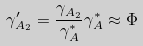Convert formula to latex. <formula><loc_0><loc_0><loc_500><loc_500>\gamma ^ { \prime } _ { A _ { 2 } } = \frac { \gamma _ { A _ { 2 } } } { \gamma ^ { \ast } _ { A } } { \gamma ^ { \ast } _ { A } } \approx \Phi</formula> 